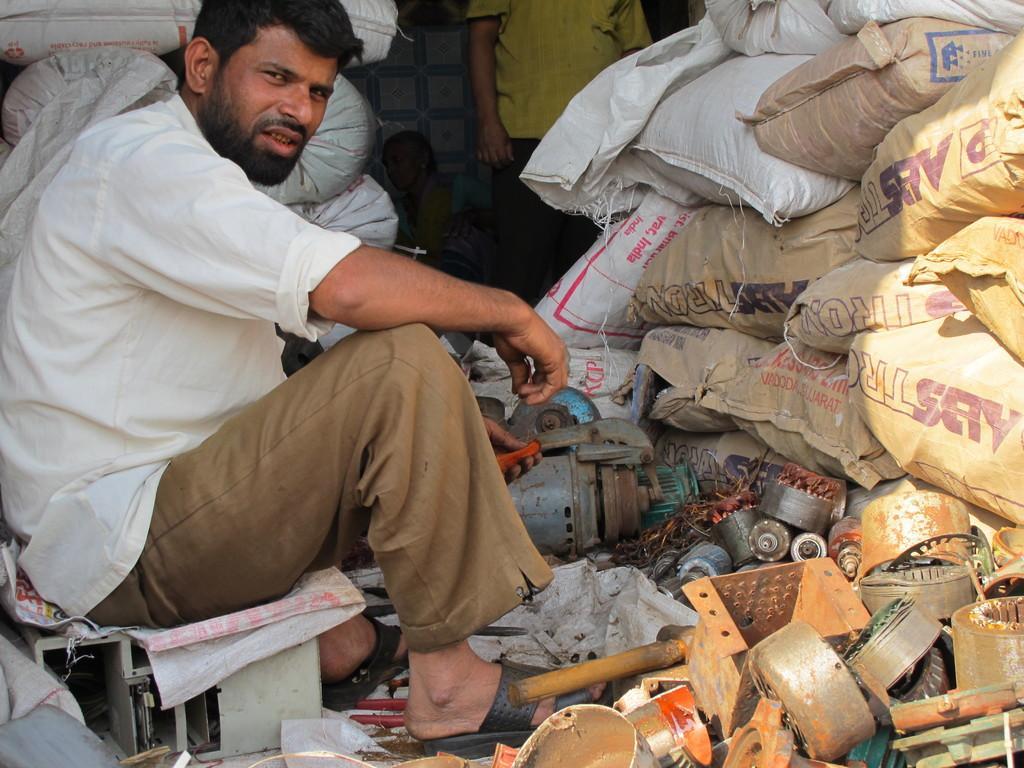Describe this image in one or two sentences. In this image I can see a man is sitting. Here I can see he is wearing white shirt, brown pant and black slippers. I can also see number of bags, trash and on these bags I can see something is written. I can also see one person in background. 